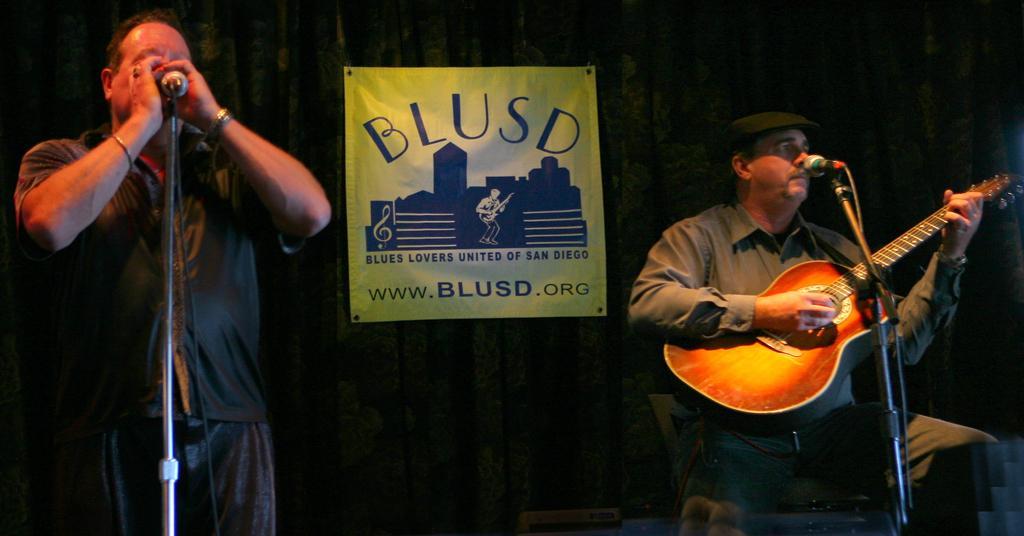Please provide a concise description of this image. In this image we can see the person sitting on the right side of the image is holding a guitar and playing it. On the left side of the image we can see a man singing through the mic. In the background there is a poster. 